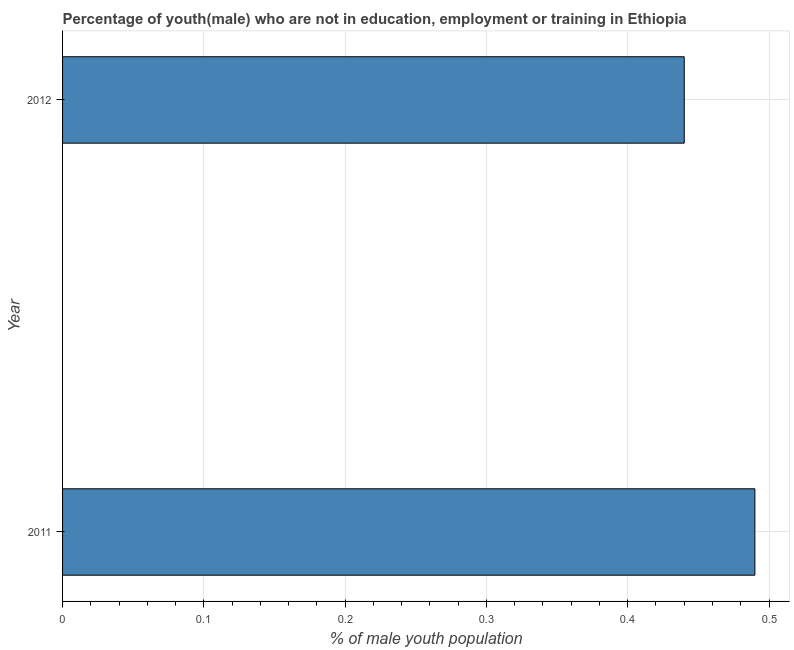What is the title of the graph?
Your response must be concise. Percentage of youth(male) who are not in education, employment or training in Ethiopia. What is the label or title of the X-axis?
Offer a very short reply. % of male youth population. What is the unemployed male youth population in 2012?
Provide a short and direct response. 0.44. Across all years, what is the maximum unemployed male youth population?
Give a very brief answer. 0.49. Across all years, what is the minimum unemployed male youth population?
Give a very brief answer. 0.44. What is the sum of the unemployed male youth population?
Keep it short and to the point. 0.93. What is the difference between the unemployed male youth population in 2011 and 2012?
Your response must be concise. 0.05. What is the average unemployed male youth population per year?
Provide a short and direct response. 0.47. What is the median unemployed male youth population?
Provide a succinct answer. 0.47. In how many years, is the unemployed male youth population greater than 0.12 %?
Make the answer very short. 2. Do a majority of the years between 2011 and 2012 (inclusive) have unemployed male youth population greater than 0.26 %?
Offer a terse response. Yes. What is the ratio of the unemployed male youth population in 2011 to that in 2012?
Provide a short and direct response. 1.11. Is the unemployed male youth population in 2011 less than that in 2012?
Ensure brevity in your answer.  No. In how many years, is the unemployed male youth population greater than the average unemployed male youth population taken over all years?
Your answer should be very brief. 1. Are all the bars in the graph horizontal?
Keep it short and to the point. Yes. Are the values on the major ticks of X-axis written in scientific E-notation?
Ensure brevity in your answer.  No. What is the % of male youth population of 2011?
Provide a succinct answer. 0.49. What is the % of male youth population in 2012?
Keep it short and to the point. 0.44. What is the ratio of the % of male youth population in 2011 to that in 2012?
Your response must be concise. 1.11. 